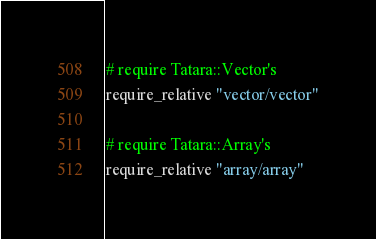Convert code to text. <code><loc_0><loc_0><loc_500><loc_500><_Ruby_>
# require Tatara::Vector's
require_relative "vector/vector"

# require Tatara::Array's
require_relative "array/array"
</code> 